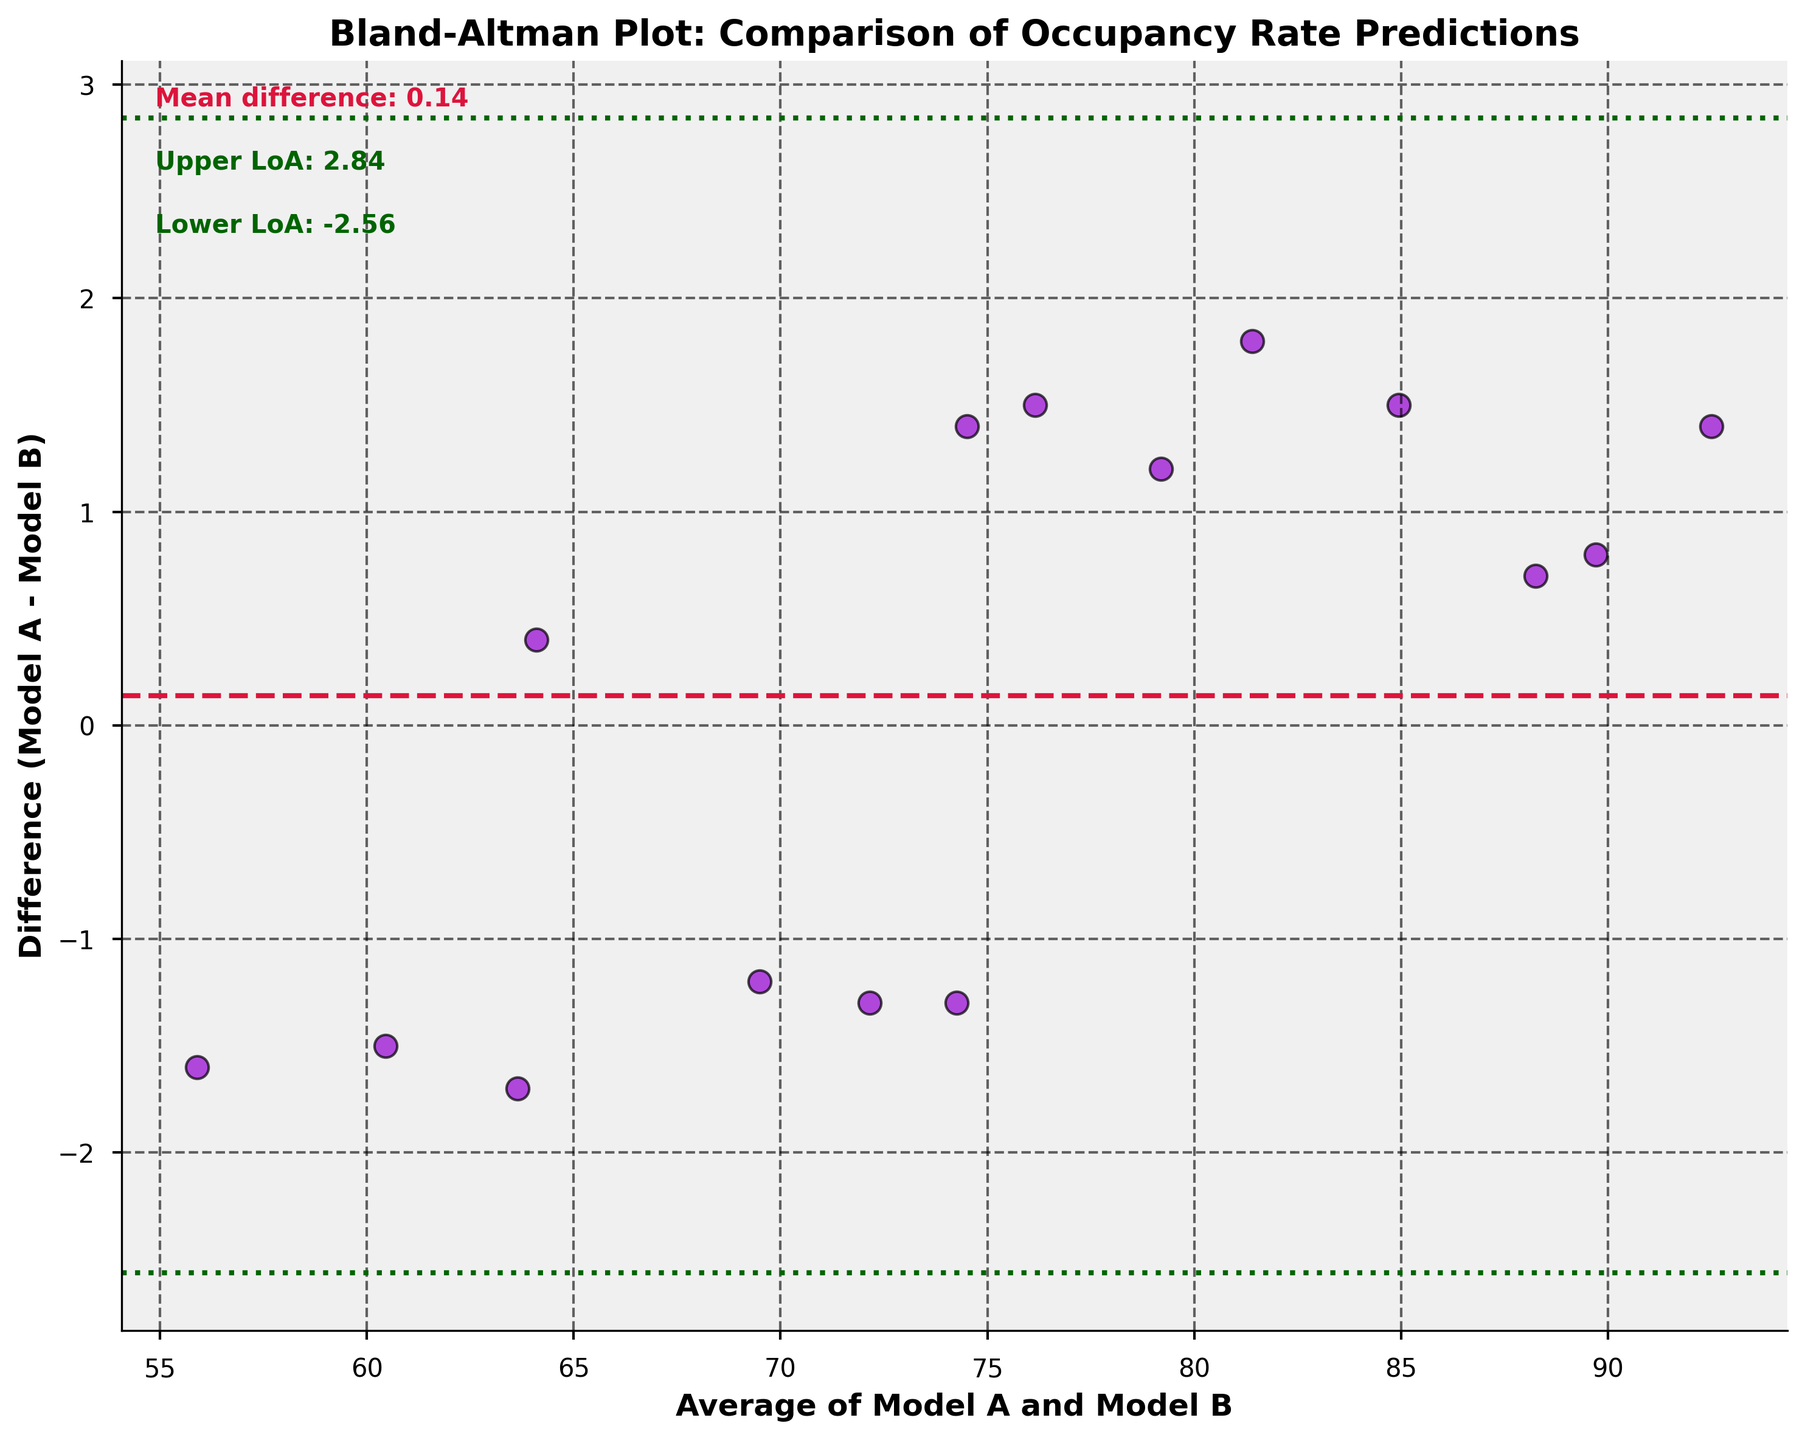What is the title of the plot? The title of the plot is written at the top and it says, "Bland-Altman Plot: Comparison of Occupancy Rate Predictions."
Answer: Bland-Altman Plot: Comparison of Occupancy Rate Predictions What does the x-axis represent? The x-axis represents the average of Model A and Model B, as indicated by the label beneath the axis.
Answer: Average of Model A and Model B What does the y-axis represent? The y-axis represents the difference between Model A and Model B, specifically "Model A - Model B," as indicated by the y-axis label.
Answer: Difference (Model A - Model B) How many data points are shown in the plot? There are 15 data points shown in the plot, as indicated by the number of entries in the provided data table.
Answer: 15 What color is used for the data point markers? The data point markers are colored dark violet, as seen in the visual representation of the scatter plot.
Answer: Dark violet What is the mean difference between the models? The mean difference is indicated by the horizontal crimson dashed line on the plot and the accompanying text, which states "Mean difference: 0.27."
Answer: 0.27 What are the limits of agreement? The limits of agreement are shown as horizontal dark green dotted lines, with text annotations "Upper LoA: 2.54" and "Lower LoA: -2.01."
Answer: -2.01 and 2.54 Is the mean difference above or below 0? The mean difference is 0.27, as indicated by the crimson dashed line. Since 0.27 is greater than 0, it is above 0.
Answer: Above 0 How many data points fall outside the limits of agreement? To determine this, we count the data points that are above 2.54 or below -2.01. In the plot, all data points fall within these limits.
Answer: 0 Do more data points have a positive or negative difference? To find this, count the data points above and below the mean difference line (0 on the y-axis). There are 9 positive differences and 6 negative differences based on their positions relative to the mean difference line.
Answer: Positive 